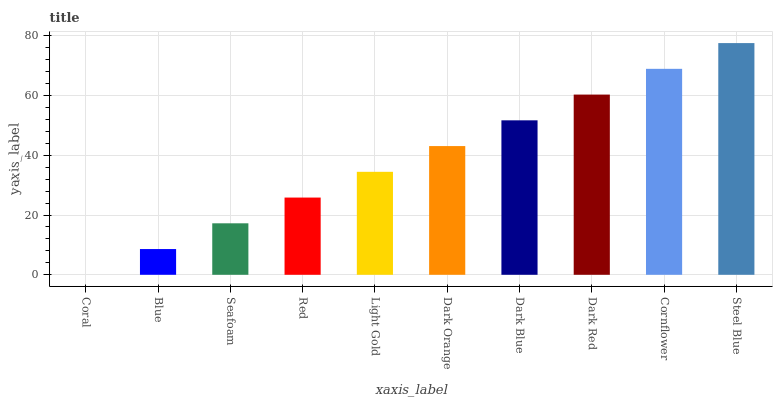Is Blue the minimum?
Answer yes or no. No. Is Blue the maximum?
Answer yes or no. No. Is Blue greater than Coral?
Answer yes or no. Yes. Is Coral less than Blue?
Answer yes or no. Yes. Is Coral greater than Blue?
Answer yes or no. No. Is Blue less than Coral?
Answer yes or no. No. Is Dark Orange the high median?
Answer yes or no. Yes. Is Light Gold the low median?
Answer yes or no. Yes. Is Seafoam the high median?
Answer yes or no. No. Is Dark Orange the low median?
Answer yes or no. No. 